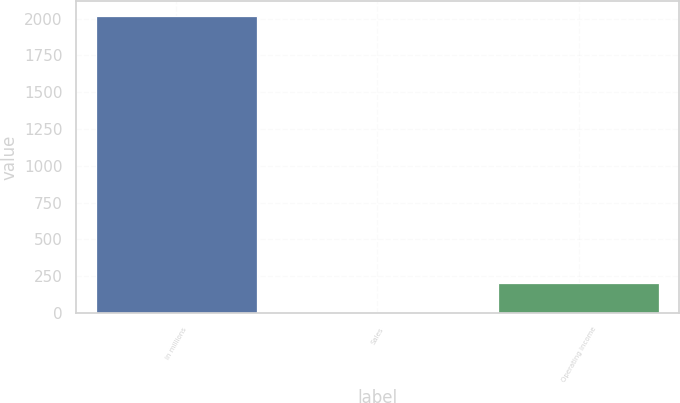Convert chart. <chart><loc_0><loc_0><loc_500><loc_500><bar_chart><fcel>in millions<fcel>Sales<fcel>Operating income<nl><fcel>2018<fcel>2<fcel>203.6<nl></chart> 